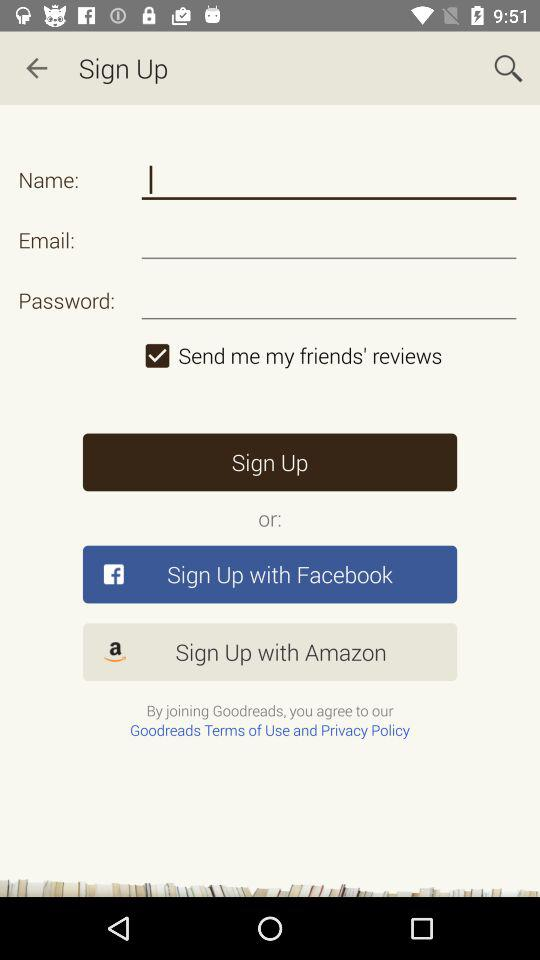What is the status of "Send me my friends' reviews"? The status is "on". 